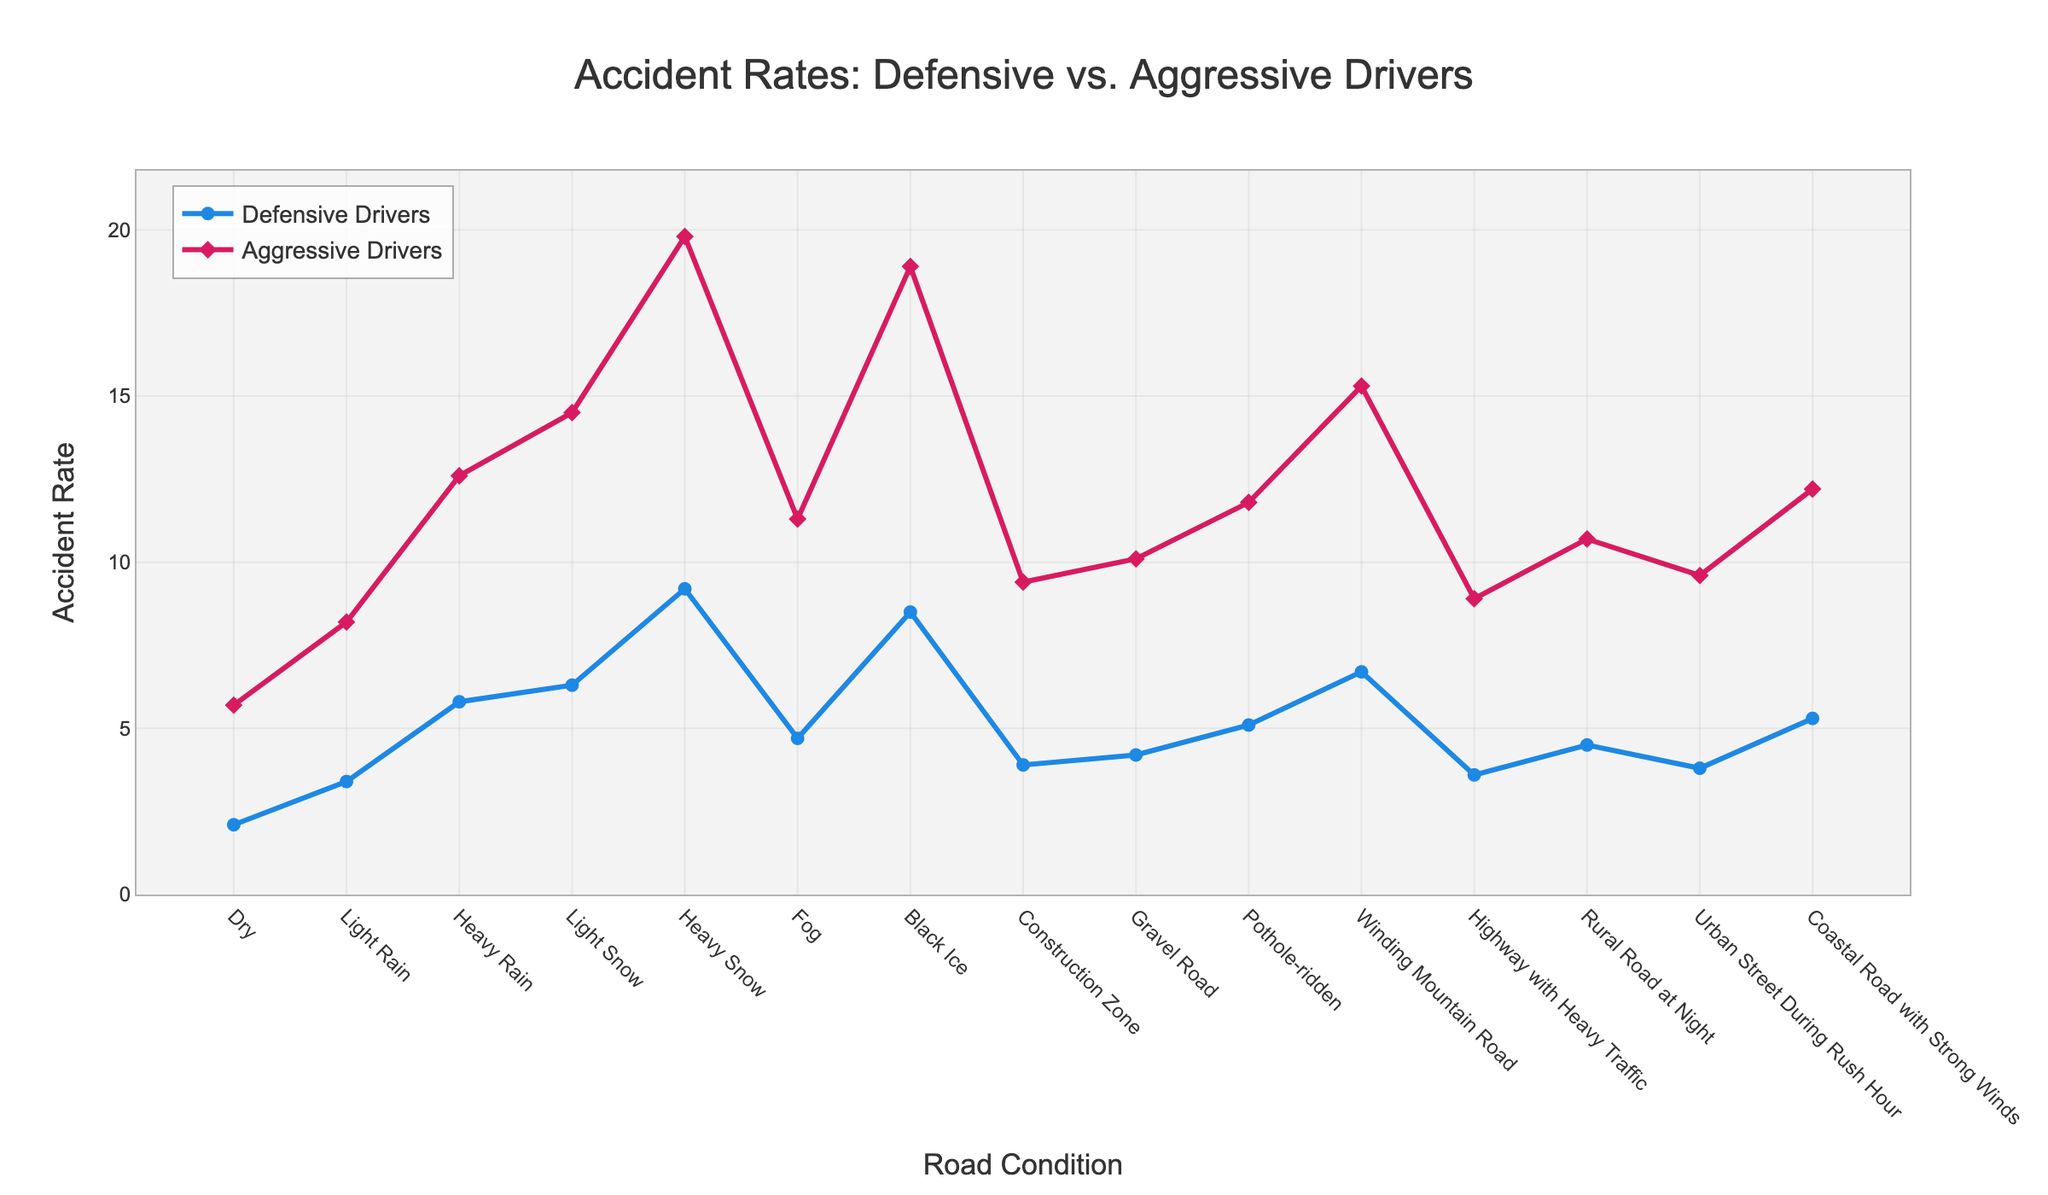What's the accident rate for defensive drivers on a dry road? Locate the "Dry" road condition on the x-axis, then find the corresponding point for "Defensive Drivers" on the y-axis. The value is 2.1.
Answer: 2.1 Which road condition shows the greatest difference in accident rates between defensive and aggressive drivers? Look at the vertical gaps between the lines for "Defensive Drivers" and "Aggressive Drivers" across all road conditions. The largest gap is observed at "Heavy Snow", where the difference is calculated as 19.8 - 9.2 = 10.6.
Answer: Heavy Snow Are accident rates for defensive drivers always lower than aggressive drivers across all road conditions? Compare the lines for "Defensive Drivers" and "Aggressive Drivers" for every road condition along the x-axis. The defensive line is always below the aggressive line, indicating lower rates.
Answer: Yes On which road condition do defensive drivers have the highest accident rate? Identify the highest point on the line for "Defensive Drivers". This occurs at "Heavy Snow" with a value of 9.2.
Answer: Heavy Snow What is the difference in accident rate between defensive and aggressive drivers on a gravel road? Find the difference between the values for "Defensive Drivers" and "Aggressive Drivers" at "Gravel Road". The difference is 10.1 - 4.2 = 5.9.
Answer: 5.9 Which road condition causes a sudden increase in accident rates for both defensive and aggressive drivers compared to the previous condition? Look for steep rises in both lines. Transitioning from "Dry" to "Light Rain" and from "Heavy Rain" to "Light Snow" both show considerable increases.
Answer: Light Rain, Light Snow 